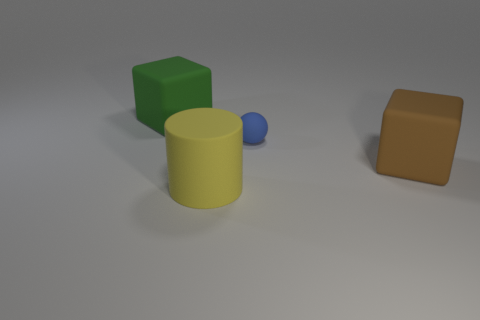How many objects are matte cubes on the right side of the large green matte object or small blue matte balls?
Your answer should be compact. 2. Are any small gray matte cubes visible?
Keep it short and to the point. No. What number of large things are either blue balls or green cubes?
Provide a short and direct response. 1. The cylinder has what color?
Make the answer very short. Yellow. There is a large block that is to the right of the big green matte thing; is there a blue object that is in front of it?
Keep it short and to the point. No. Is the number of large matte blocks that are in front of the blue matte sphere less than the number of big blocks?
Ensure brevity in your answer.  Yes. Do the big cube that is on the left side of the blue object and the big brown block have the same material?
Your answer should be compact. Yes. There is a large cylinder that is made of the same material as the tiny object; what color is it?
Give a very brief answer. Yellow. Are there fewer rubber balls behind the ball than rubber cylinders that are in front of the yellow matte object?
Offer a terse response. No. Are there any tiny cyan cylinders that have the same material as the large green object?
Your answer should be compact. No. 